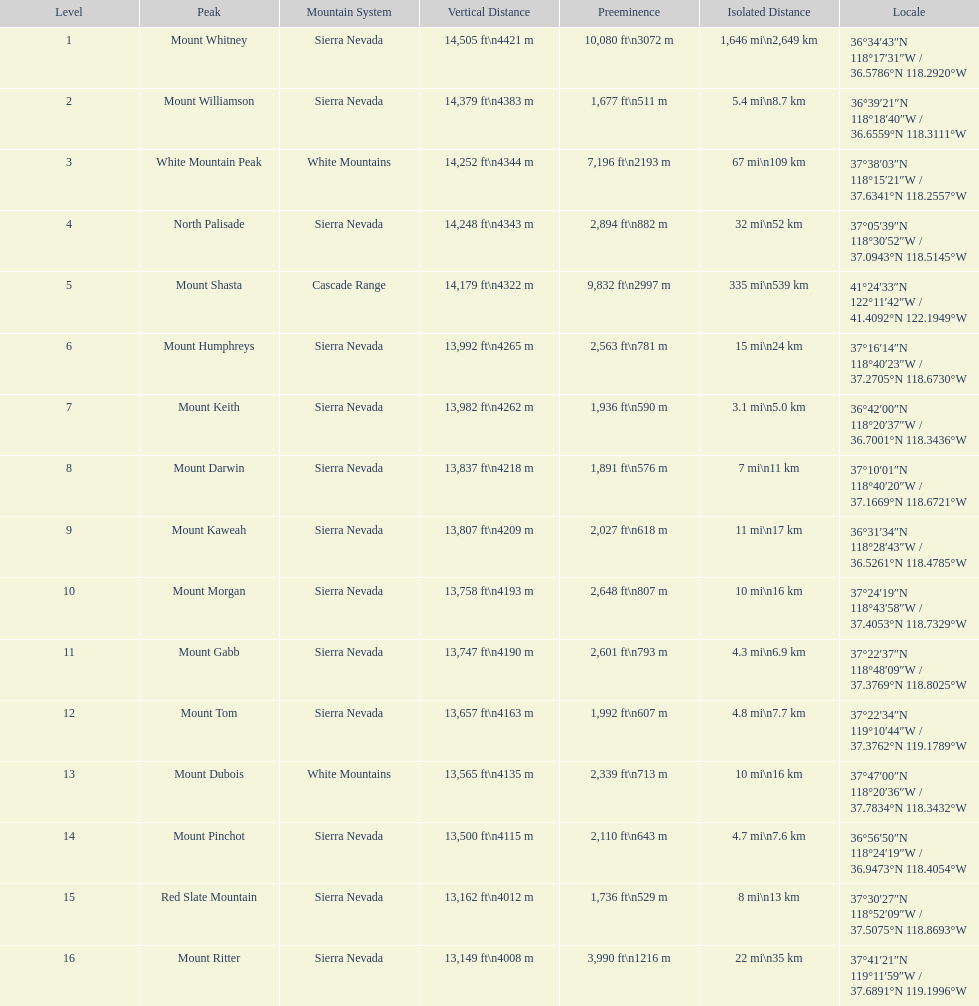Which peak has a prominence of over 10,000 feet? Mount Whitney. 